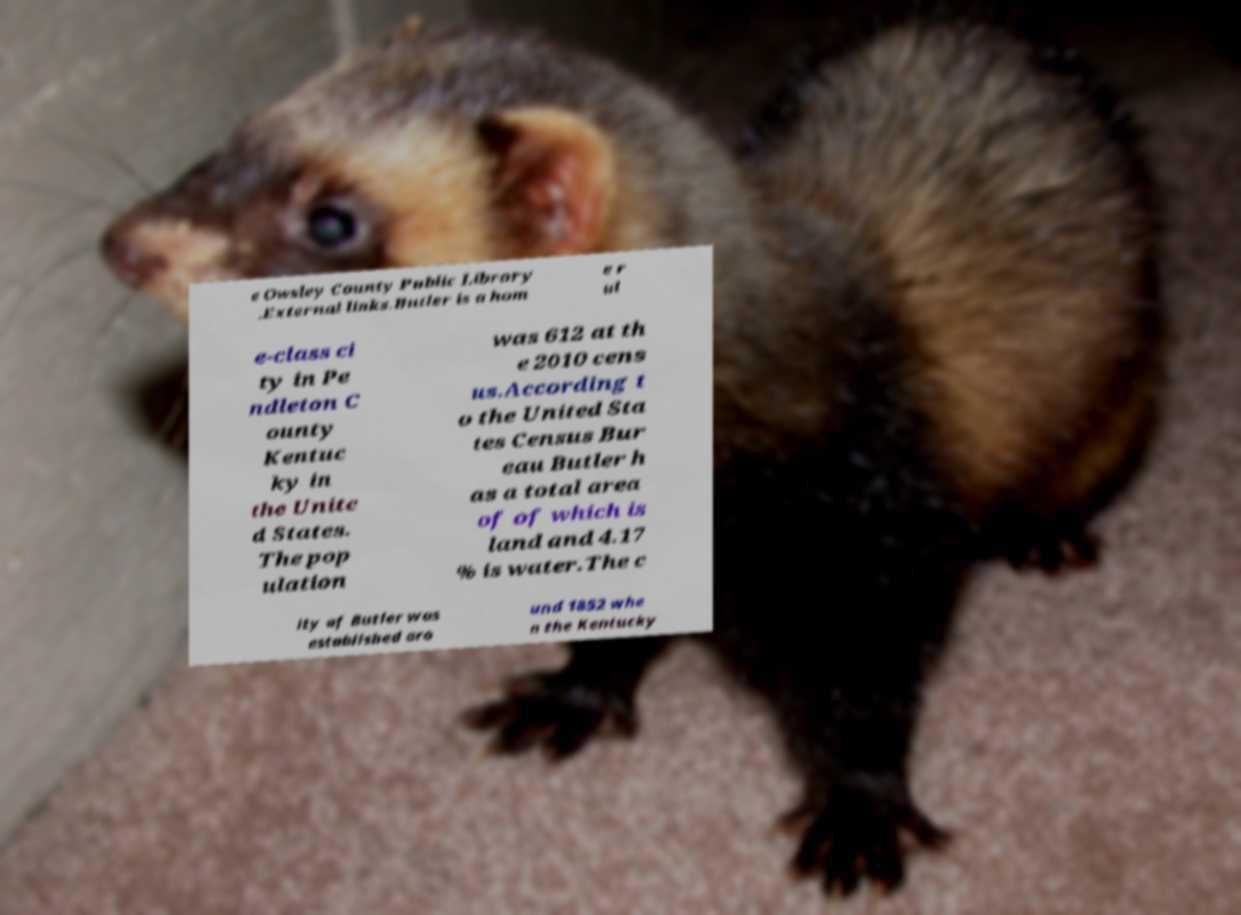Can you read and provide the text displayed in the image?This photo seems to have some interesting text. Can you extract and type it out for me? e Owsley County Public Library .External links.Butler is a hom e r ul e-class ci ty in Pe ndleton C ounty Kentuc ky in the Unite d States. The pop ulation was 612 at th e 2010 cens us.According t o the United Sta tes Census Bur eau Butler h as a total area of of which is land and 4.17 % is water.The c ity of Butler was established aro und 1852 whe n the Kentucky 